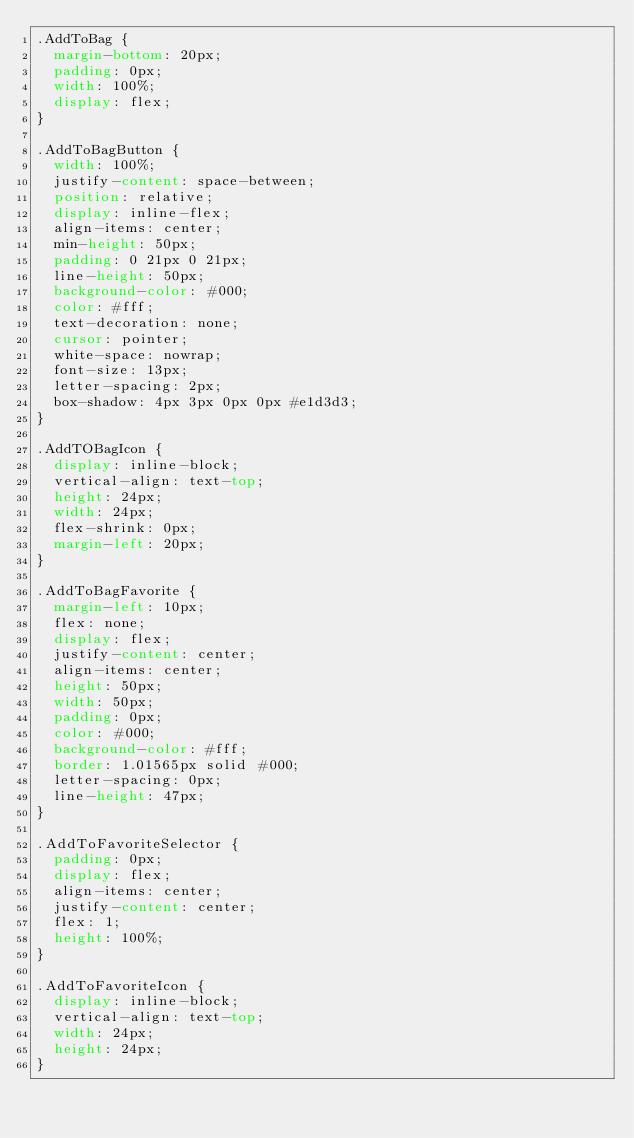Convert code to text. <code><loc_0><loc_0><loc_500><loc_500><_CSS_>.AddToBag {
  margin-bottom: 20px;
  padding: 0px;
  width: 100%;
  display: flex;
}

.AddToBagButton {
  width: 100%;
  justify-content: space-between;
  position: relative;
  display: inline-flex;
  align-items: center;
  min-height: 50px;
  padding: 0 21px 0 21px;
  line-height: 50px;
  background-color: #000;
  color: #fff;
  text-decoration: none;
  cursor: pointer;
  white-space: nowrap;
  font-size: 13px;
  letter-spacing: 2px;
  box-shadow: 4px 3px 0px 0px #e1d3d3;
}

.AddTOBagIcon {
  display: inline-block;
  vertical-align: text-top;
  height: 24px;
  width: 24px;
  flex-shrink: 0px;
  margin-left: 20px;
}

.AddToBagFavorite {
  margin-left: 10px;
  flex: none;
  display: flex;
  justify-content: center;
  align-items: center;
  height: 50px;
  width: 50px;
  padding: 0px;
  color: #000;
  background-color: #fff;
  border: 1.01565px solid #000;
  letter-spacing: 0px;
  line-height: 47px;
}

.AddToFavoriteSelector {
  padding: 0px;
  display: flex;
  align-items: center;
  justify-content: center;
  flex: 1;
  height: 100%;
}

.AddToFavoriteIcon {
  display: inline-block;
  vertical-align: text-top;
  width: 24px;
  height: 24px;
}
</code> 